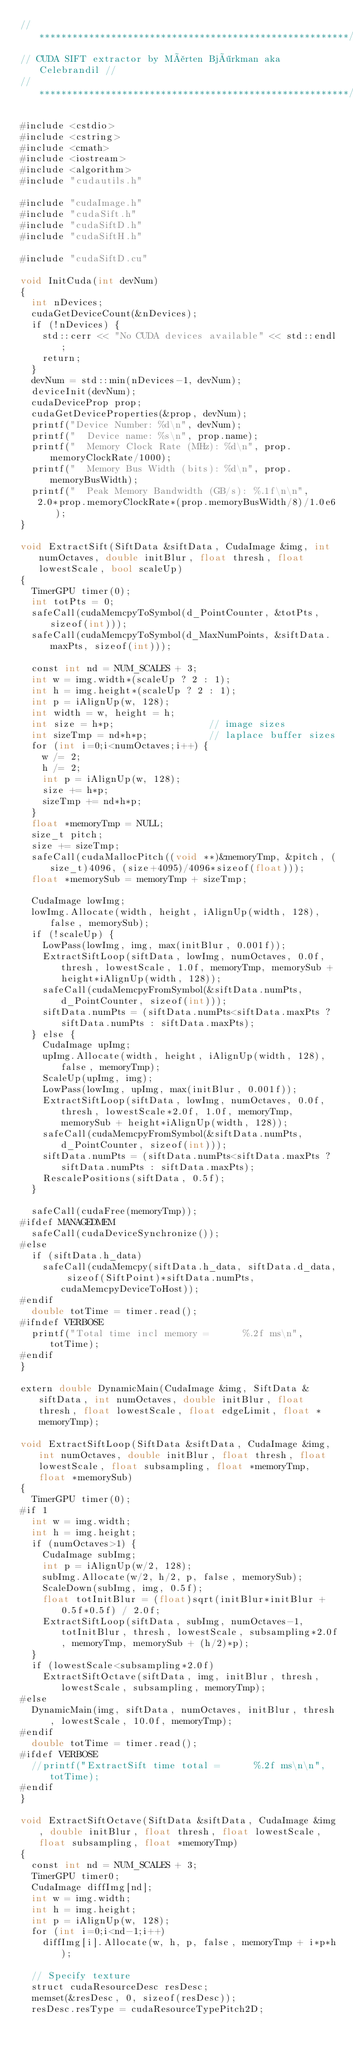<code> <loc_0><loc_0><loc_500><loc_500><_Cuda_>//********************************************************//
// CUDA SIFT extractor by Mårten Björkman aka Celebrandil //
//********************************************************//  

#include <cstdio>
#include <cstring>
#include <cmath>
#include <iostream>
#include <algorithm>
#include "cudautils.h"

#include "cudaImage.h"
#include "cudaSift.h"
#include "cudaSiftD.h"
#include "cudaSiftH.h"

#include "cudaSiftD.cu"

void InitCuda(int devNum)
{
  int nDevices;
  cudaGetDeviceCount(&nDevices);
  if (!nDevices) {
    std::cerr << "No CUDA devices available" << std::endl;
    return;
  }
  devNum = std::min(nDevices-1, devNum);
  deviceInit(devNum);  
  cudaDeviceProp prop;
  cudaGetDeviceProperties(&prop, devNum);
  printf("Device Number: %d\n", devNum);
  printf("  Device name: %s\n", prop.name);
  printf("  Memory Clock Rate (MHz): %d\n", prop.memoryClockRate/1000);
  printf("  Memory Bus Width (bits): %d\n", prop.memoryBusWidth);
  printf("  Peak Memory Bandwidth (GB/s): %.1f\n\n",
	 2.0*prop.memoryClockRate*(prop.memoryBusWidth/8)/1.0e6);
}

void ExtractSift(SiftData &siftData, CudaImage &img, int numOctaves, double initBlur, float thresh, float lowestScale, bool scaleUp) 
{
  TimerGPU timer(0);
  int totPts = 0;
  safeCall(cudaMemcpyToSymbol(d_PointCounter, &totPts, sizeof(int)));
  safeCall(cudaMemcpyToSymbol(d_MaxNumPoints, &siftData.maxPts, sizeof(int)));

  const int nd = NUM_SCALES + 3;
  int w = img.width*(scaleUp ? 2 : 1);
  int h = img.height*(scaleUp ? 2 : 1);
  int p = iAlignUp(w, 128);
  int width = w, height = h;
  int size = h*p;                 // image sizes
  int sizeTmp = nd*h*p;           // laplace buffer sizes
  for (int i=0;i<numOctaves;i++) {
    w /= 2;
    h /= 2;
    int p = iAlignUp(w, 128);
    size += h*p;
    sizeTmp += nd*h*p; 
  }
  float *memoryTmp = NULL; 
  size_t pitch;
  size += sizeTmp;
  safeCall(cudaMallocPitch((void **)&memoryTmp, &pitch, (size_t)4096, (size+4095)/4096*sizeof(float)));
  float *memorySub = memoryTmp + sizeTmp;

  CudaImage lowImg;
  lowImg.Allocate(width, height, iAlignUp(width, 128), false, memorySub);
  if (!scaleUp) {
    LowPass(lowImg, img, max(initBlur, 0.001f));
    ExtractSiftLoop(siftData, lowImg, numOctaves, 0.0f, thresh, lowestScale, 1.0f, memoryTmp, memorySub + height*iAlignUp(width, 128));
    safeCall(cudaMemcpyFromSymbol(&siftData.numPts, d_PointCounter, sizeof(int)));
    siftData.numPts = (siftData.numPts<siftData.maxPts ? siftData.numPts : siftData.maxPts);
  } else {
    CudaImage upImg;
    upImg.Allocate(width, height, iAlignUp(width, 128), false, memoryTmp);
    ScaleUp(upImg, img);
    LowPass(lowImg, upImg, max(initBlur, 0.001f));
    ExtractSiftLoop(siftData, lowImg, numOctaves, 0.0f, thresh, lowestScale*2.0f, 1.0f, memoryTmp, memorySub + height*iAlignUp(width, 128));
    safeCall(cudaMemcpyFromSymbol(&siftData.numPts, d_PointCounter, sizeof(int)));
    siftData.numPts = (siftData.numPts<siftData.maxPts ? siftData.numPts : siftData.maxPts);
    RescalePositions(siftData, 0.5f);
  }
  
  safeCall(cudaFree(memoryTmp));
#ifdef MANAGEDMEM
  safeCall(cudaDeviceSynchronize());
#else
  if (siftData.h_data)
    safeCall(cudaMemcpy(siftData.h_data, siftData.d_data, sizeof(SiftPoint)*siftData.numPts, cudaMemcpyDeviceToHost));
#endif
  double totTime = timer.read();
#ifndef VERBOSE
  printf("Total time incl memory =      %.2f ms\n", totTime);
#endif
}

extern double DynamicMain(CudaImage &img, SiftData &siftData, int numOctaves, double initBlur, float thresh, float lowestScale, float edgeLimit, float *memoryTmp);

void ExtractSiftLoop(SiftData &siftData, CudaImage &img, int numOctaves, double initBlur, float thresh, float lowestScale, float subsampling, float *memoryTmp, float *memorySub) 
{
  TimerGPU timer(0);
#if 1
  int w = img.width;
  int h = img.height;
  if (numOctaves>1) {
    CudaImage subImg;
    int p = iAlignUp(w/2, 128);
    subImg.Allocate(w/2, h/2, p, false, memorySub); 
    ScaleDown(subImg, img, 0.5f);
    float totInitBlur = (float)sqrt(initBlur*initBlur + 0.5f*0.5f) / 2.0f;
    ExtractSiftLoop(siftData, subImg, numOctaves-1, totInitBlur, thresh, lowestScale, subsampling*2.0f, memoryTmp, memorySub + (h/2)*p);
  }
  if (lowestScale<subsampling*2.0f) 
    ExtractSiftOctave(siftData, img, initBlur, thresh, lowestScale, subsampling, memoryTmp);
#else
  DynamicMain(img, siftData, numOctaves, initBlur, thresh, lowestScale, 10.0f, memoryTmp);
#endif
  double totTime = timer.read();
#ifdef VERBOSE
  //printf("ExtractSift time total =      %.2f ms\n\n", totTime);
#endif
}

void ExtractSiftOctave(SiftData &siftData, CudaImage &img, double initBlur, float thresh, float lowestScale, float subsampling, float *memoryTmp)
{
  const int nd = NUM_SCALES + 3;
  TimerGPU timer0;
  CudaImage diffImg[nd];
  int w = img.width; 
  int h = img.height;
  int p = iAlignUp(w, 128);
  for (int i=0;i<nd-1;i++) 
    diffImg[i].Allocate(w, h, p, false, memoryTmp + i*p*h); 

  // Specify texture
  struct cudaResourceDesc resDesc;
  memset(&resDesc, 0, sizeof(resDesc));
  resDesc.resType = cudaResourceTypePitch2D;</code> 